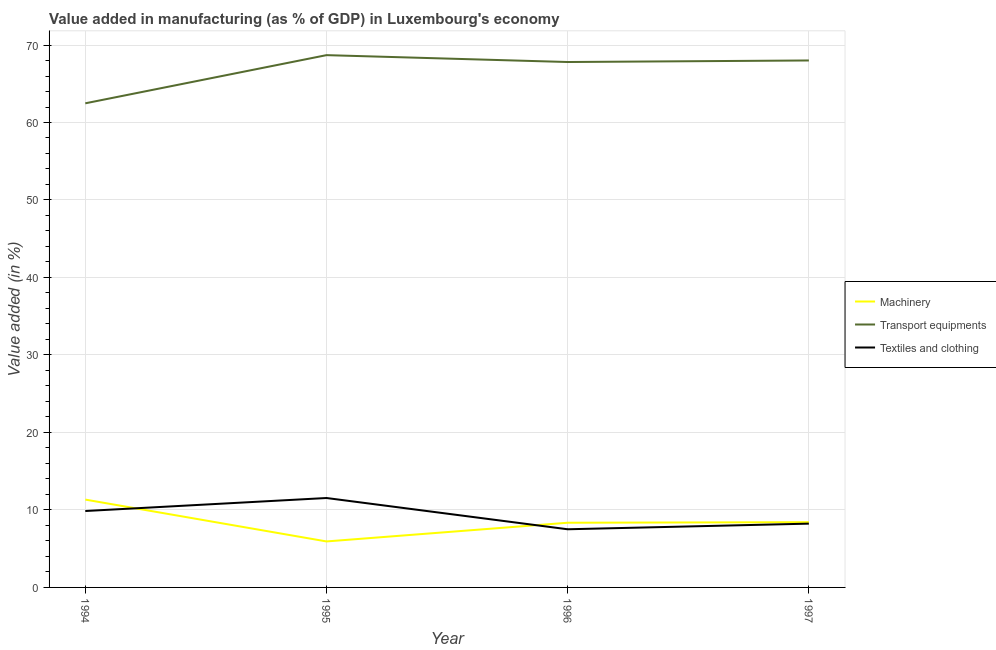How many different coloured lines are there?
Offer a terse response. 3. What is the value added in manufacturing machinery in 1995?
Provide a short and direct response. 5.94. Across all years, what is the maximum value added in manufacturing machinery?
Give a very brief answer. 11.34. Across all years, what is the minimum value added in manufacturing machinery?
Offer a very short reply. 5.94. What is the total value added in manufacturing transport equipments in the graph?
Provide a succinct answer. 266.98. What is the difference between the value added in manufacturing machinery in 1994 and that in 1997?
Provide a short and direct response. 2.92. What is the difference between the value added in manufacturing machinery in 1997 and the value added in manufacturing transport equipments in 1996?
Give a very brief answer. -59.39. What is the average value added in manufacturing textile and clothing per year?
Provide a succinct answer. 9.28. In the year 1997, what is the difference between the value added in manufacturing machinery and value added in manufacturing textile and clothing?
Ensure brevity in your answer.  0.19. What is the ratio of the value added in manufacturing textile and clothing in 1994 to that in 1996?
Your answer should be very brief. 1.31. Is the value added in manufacturing textile and clothing in 1994 less than that in 1997?
Offer a very short reply. No. What is the difference between the highest and the second highest value added in manufacturing transport equipments?
Keep it short and to the point. 0.69. What is the difference between the highest and the lowest value added in manufacturing machinery?
Provide a succinct answer. 5.4. In how many years, is the value added in manufacturing textile and clothing greater than the average value added in manufacturing textile and clothing taken over all years?
Provide a succinct answer. 2. Is the sum of the value added in manufacturing textile and clothing in 1996 and 1997 greater than the maximum value added in manufacturing machinery across all years?
Provide a short and direct response. Yes. Is it the case that in every year, the sum of the value added in manufacturing machinery and value added in manufacturing transport equipments is greater than the value added in manufacturing textile and clothing?
Offer a very short reply. Yes. Is the value added in manufacturing machinery strictly greater than the value added in manufacturing transport equipments over the years?
Offer a terse response. No. How many years are there in the graph?
Provide a succinct answer. 4. What is the difference between two consecutive major ticks on the Y-axis?
Your answer should be very brief. 10. Does the graph contain any zero values?
Offer a terse response. No. Where does the legend appear in the graph?
Your answer should be very brief. Center right. How many legend labels are there?
Give a very brief answer. 3. How are the legend labels stacked?
Offer a terse response. Vertical. What is the title of the graph?
Keep it short and to the point. Value added in manufacturing (as % of GDP) in Luxembourg's economy. What is the label or title of the Y-axis?
Offer a terse response. Value added (in %). What is the Value added (in %) of Machinery in 1994?
Make the answer very short. 11.34. What is the Value added (in %) in Transport equipments in 1994?
Offer a terse response. 62.48. What is the Value added (in %) of Textiles and clothing in 1994?
Offer a terse response. 9.86. What is the Value added (in %) in Machinery in 1995?
Offer a terse response. 5.94. What is the Value added (in %) in Transport equipments in 1995?
Keep it short and to the point. 68.69. What is the Value added (in %) in Textiles and clothing in 1995?
Provide a short and direct response. 11.54. What is the Value added (in %) in Machinery in 1996?
Provide a succinct answer. 8.35. What is the Value added (in %) of Transport equipments in 1996?
Keep it short and to the point. 67.81. What is the Value added (in %) of Textiles and clothing in 1996?
Make the answer very short. 7.51. What is the Value added (in %) in Machinery in 1997?
Give a very brief answer. 8.42. What is the Value added (in %) of Transport equipments in 1997?
Ensure brevity in your answer.  68.01. What is the Value added (in %) in Textiles and clothing in 1997?
Provide a short and direct response. 8.23. Across all years, what is the maximum Value added (in %) of Machinery?
Your answer should be very brief. 11.34. Across all years, what is the maximum Value added (in %) in Transport equipments?
Offer a very short reply. 68.69. Across all years, what is the maximum Value added (in %) of Textiles and clothing?
Provide a short and direct response. 11.54. Across all years, what is the minimum Value added (in %) in Machinery?
Give a very brief answer. 5.94. Across all years, what is the minimum Value added (in %) in Transport equipments?
Your answer should be compact. 62.48. Across all years, what is the minimum Value added (in %) of Textiles and clothing?
Give a very brief answer. 7.51. What is the total Value added (in %) in Machinery in the graph?
Keep it short and to the point. 34.04. What is the total Value added (in %) of Transport equipments in the graph?
Your answer should be very brief. 266.98. What is the total Value added (in %) in Textiles and clothing in the graph?
Provide a short and direct response. 37.14. What is the difference between the Value added (in %) in Machinery in 1994 and that in 1995?
Ensure brevity in your answer.  5.4. What is the difference between the Value added (in %) of Transport equipments in 1994 and that in 1995?
Provide a succinct answer. -6.22. What is the difference between the Value added (in %) of Textiles and clothing in 1994 and that in 1995?
Provide a short and direct response. -1.68. What is the difference between the Value added (in %) of Machinery in 1994 and that in 1996?
Offer a terse response. 2.99. What is the difference between the Value added (in %) of Transport equipments in 1994 and that in 1996?
Ensure brevity in your answer.  -5.33. What is the difference between the Value added (in %) in Textiles and clothing in 1994 and that in 1996?
Offer a terse response. 2.36. What is the difference between the Value added (in %) of Machinery in 1994 and that in 1997?
Give a very brief answer. 2.92. What is the difference between the Value added (in %) of Transport equipments in 1994 and that in 1997?
Provide a succinct answer. -5.53. What is the difference between the Value added (in %) of Textiles and clothing in 1994 and that in 1997?
Your answer should be compact. 1.63. What is the difference between the Value added (in %) of Machinery in 1995 and that in 1996?
Your answer should be compact. -2.41. What is the difference between the Value added (in %) of Transport equipments in 1995 and that in 1996?
Give a very brief answer. 0.89. What is the difference between the Value added (in %) in Textiles and clothing in 1995 and that in 1996?
Make the answer very short. 4.03. What is the difference between the Value added (in %) in Machinery in 1995 and that in 1997?
Provide a succinct answer. -2.48. What is the difference between the Value added (in %) of Transport equipments in 1995 and that in 1997?
Your answer should be compact. 0.69. What is the difference between the Value added (in %) of Textiles and clothing in 1995 and that in 1997?
Make the answer very short. 3.31. What is the difference between the Value added (in %) of Machinery in 1996 and that in 1997?
Provide a succinct answer. -0.07. What is the difference between the Value added (in %) of Transport equipments in 1996 and that in 1997?
Provide a short and direct response. -0.2. What is the difference between the Value added (in %) in Textiles and clothing in 1996 and that in 1997?
Offer a terse response. -0.73. What is the difference between the Value added (in %) in Machinery in 1994 and the Value added (in %) in Transport equipments in 1995?
Ensure brevity in your answer.  -57.36. What is the difference between the Value added (in %) in Machinery in 1994 and the Value added (in %) in Textiles and clothing in 1995?
Provide a short and direct response. -0.2. What is the difference between the Value added (in %) of Transport equipments in 1994 and the Value added (in %) of Textiles and clothing in 1995?
Provide a short and direct response. 50.94. What is the difference between the Value added (in %) of Machinery in 1994 and the Value added (in %) of Transport equipments in 1996?
Ensure brevity in your answer.  -56.47. What is the difference between the Value added (in %) of Machinery in 1994 and the Value added (in %) of Textiles and clothing in 1996?
Ensure brevity in your answer.  3.83. What is the difference between the Value added (in %) in Transport equipments in 1994 and the Value added (in %) in Textiles and clothing in 1996?
Your response must be concise. 54.97. What is the difference between the Value added (in %) in Machinery in 1994 and the Value added (in %) in Transport equipments in 1997?
Your response must be concise. -56.67. What is the difference between the Value added (in %) in Machinery in 1994 and the Value added (in %) in Textiles and clothing in 1997?
Your answer should be compact. 3.1. What is the difference between the Value added (in %) of Transport equipments in 1994 and the Value added (in %) of Textiles and clothing in 1997?
Make the answer very short. 54.25. What is the difference between the Value added (in %) of Machinery in 1995 and the Value added (in %) of Transport equipments in 1996?
Make the answer very short. -61.87. What is the difference between the Value added (in %) of Machinery in 1995 and the Value added (in %) of Textiles and clothing in 1996?
Provide a succinct answer. -1.57. What is the difference between the Value added (in %) of Transport equipments in 1995 and the Value added (in %) of Textiles and clothing in 1996?
Offer a terse response. 61.19. What is the difference between the Value added (in %) of Machinery in 1995 and the Value added (in %) of Transport equipments in 1997?
Offer a terse response. -62.07. What is the difference between the Value added (in %) of Machinery in 1995 and the Value added (in %) of Textiles and clothing in 1997?
Keep it short and to the point. -2.3. What is the difference between the Value added (in %) of Transport equipments in 1995 and the Value added (in %) of Textiles and clothing in 1997?
Offer a terse response. 60.46. What is the difference between the Value added (in %) in Machinery in 1996 and the Value added (in %) in Transport equipments in 1997?
Offer a very short reply. -59.66. What is the difference between the Value added (in %) in Machinery in 1996 and the Value added (in %) in Textiles and clothing in 1997?
Provide a short and direct response. 0.12. What is the difference between the Value added (in %) in Transport equipments in 1996 and the Value added (in %) in Textiles and clothing in 1997?
Make the answer very short. 59.57. What is the average Value added (in %) of Machinery per year?
Keep it short and to the point. 8.51. What is the average Value added (in %) in Transport equipments per year?
Make the answer very short. 66.75. What is the average Value added (in %) of Textiles and clothing per year?
Make the answer very short. 9.28. In the year 1994, what is the difference between the Value added (in %) of Machinery and Value added (in %) of Transport equipments?
Your answer should be very brief. -51.14. In the year 1994, what is the difference between the Value added (in %) of Machinery and Value added (in %) of Textiles and clothing?
Keep it short and to the point. 1.47. In the year 1994, what is the difference between the Value added (in %) of Transport equipments and Value added (in %) of Textiles and clothing?
Offer a terse response. 52.62. In the year 1995, what is the difference between the Value added (in %) of Machinery and Value added (in %) of Transport equipments?
Your answer should be very brief. -62.76. In the year 1995, what is the difference between the Value added (in %) in Machinery and Value added (in %) in Textiles and clothing?
Provide a succinct answer. -5.6. In the year 1995, what is the difference between the Value added (in %) in Transport equipments and Value added (in %) in Textiles and clothing?
Give a very brief answer. 57.15. In the year 1996, what is the difference between the Value added (in %) of Machinery and Value added (in %) of Transport equipments?
Give a very brief answer. -59.46. In the year 1996, what is the difference between the Value added (in %) in Machinery and Value added (in %) in Textiles and clothing?
Offer a terse response. 0.84. In the year 1996, what is the difference between the Value added (in %) of Transport equipments and Value added (in %) of Textiles and clothing?
Your answer should be very brief. 60.3. In the year 1997, what is the difference between the Value added (in %) in Machinery and Value added (in %) in Transport equipments?
Your response must be concise. -59.59. In the year 1997, what is the difference between the Value added (in %) of Machinery and Value added (in %) of Textiles and clothing?
Provide a short and direct response. 0.19. In the year 1997, what is the difference between the Value added (in %) of Transport equipments and Value added (in %) of Textiles and clothing?
Offer a very short reply. 59.77. What is the ratio of the Value added (in %) of Machinery in 1994 to that in 1995?
Your answer should be compact. 1.91. What is the ratio of the Value added (in %) in Transport equipments in 1994 to that in 1995?
Keep it short and to the point. 0.91. What is the ratio of the Value added (in %) of Textiles and clothing in 1994 to that in 1995?
Give a very brief answer. 0.85. What is the ratio of the Value added (in %) in Machinery in 1994 to that in 1996?
Make the answer very short. 1.36. What is the ratio of the Value added (in %) in Transport equipments in 1994 to that in 1996?
Offer a terse response. 0.92. What is the ratio of the Value added (in %) of Textiles and clothing in 1994 to that in 1996?
Your answer should be very brief. 1.31. What is the ratio of the Value added (in %) of Machinery in 1994 to that in 1997?
Your answer should be very brief. 1.35. What is the ratio of the Value added (in %) in Transport equipments in 1994 to that in 1997?
Offer a very short reply. 0.92. What is the ratio of the Value added (in %) in Textiles and clothing in 1994 to that in 1997?
Ensure brevity in your answer.  1.2. What is the ratio of the Value added (in %) of Machinery in 1995 to that in 1996?
Offer a terse response. 0.71. What is the ratio of the Value added (in %) in Transport equipments in 1995 to that in 1996?
Keep it short and to the point. 1.01. What is the ratio of the Value added (in %) in Textiles and clothing in 1995 to that in 1996?
Ensure brevity in your answer.  1.54. What is the ratio of the Value added (in %) in Machinery in 1995 to that in 1997?
Your answer should be very brief. 0.7. What is the ratio of the Value added (in %) in Textiles and clothing in 1995 to that in 1997?
Your answer should be very brief. 1.4. What is the ratio of the Value added (in %) of Textiles and clothing in 1996 to that in 1997?
Provide a short and direct response. 0.91. What is the difference between the highest and the second highest Value added (in %) of Machinery?
Keep it short and to the point. 2.92. What is the difference between the highest and the second highest Value added (in %) in Transport equipments?
Offer a terse response. 0.69. What is the difference between the highest and the second highest Value added (in %) in Textiles and clothing?
Ensure brevity in your answer.  1.68. What is the difference between the highest and the lowest Value added (in %) in Machinery?
Offer a very short reply. 5.4. What is the difference between the highest and the lowest Value added (in %) in Transport equipments?
Give a very brief answer. 6.22. What is the difference between the highest and the lowest Value added (in %) of Textiles and clothing?
Offer a very short reply. 4.03. 